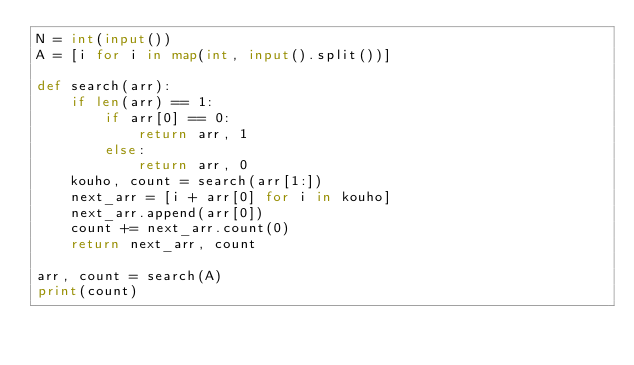Convert code to text. <code><loc_0><loc_0><loc_500><loc_500><_Python_>N = int(input())
A = [i for i in map(int, input().split())]

def search(arr):
    if len(arr) == 1:
        if arr[0] == 0:
            return arr, 1
        else:
            return arr, 0
    kouho, count = search(arr[1:])
    next_arr = [i + arr[0] for i in kouho]
    next_arr.append(arr[0])
    count += next_arr.count(0)
    return next_arr, count

arr, count = search(A)
print(count)
</code> 